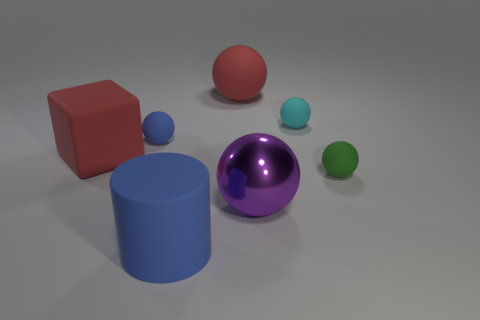Subtract all cyan spheres. How many spheres are left? 4 Subtract all green spheres. How many spheres are left? 4 Add 2 red balls. How many objects exist? 9 Subtract 1 balls. How many balls are left? 4 Add 5 large blocks. How many large blocks exist? 6 Subtract 0 brown cylinders. How many objects are left? 7 Subtract all blocks. How many objects are left? 6 Subtract all blue spheres. Subtract all red cubes. How many spheres are left? 4 Subtract all gray cylinders. How many gray blocks are left? 0 Subtract all cyan rubber balls. Subtract all big blue matte things. How many objects are left? 5 